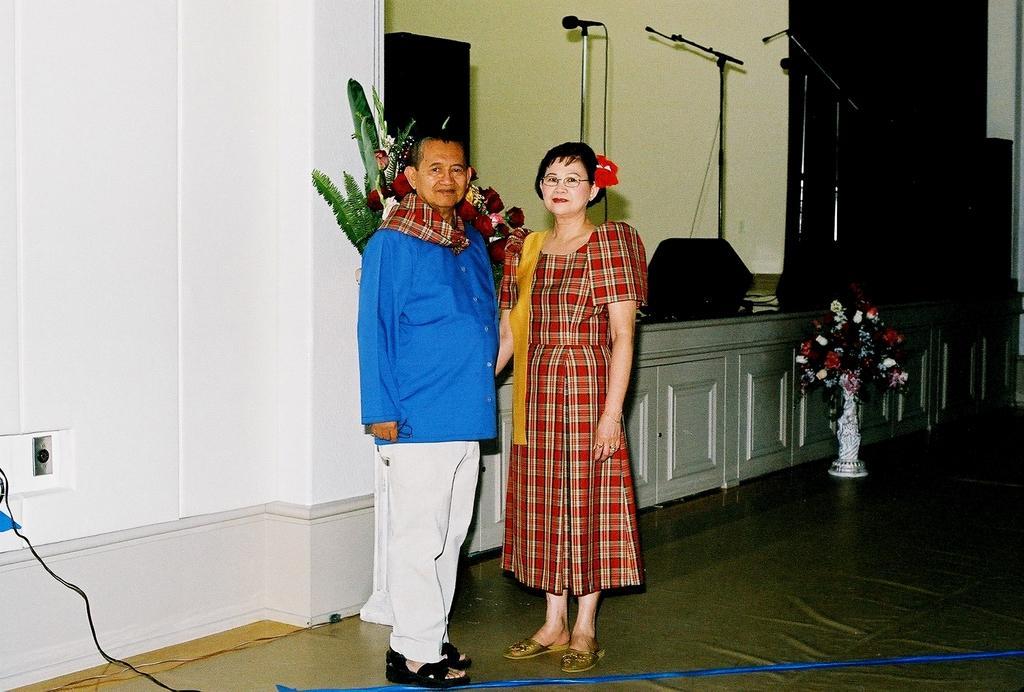In one or two sentences, can you explain what this image depicts? In this image in the center there are two persons who are standing, and in the background there is a table. On the table there is one flower bouquet and beside the table there is one pot and flowers, and on the table there are some mike's, speaker and some wires and on the left side there is a wall. At the bottom there is a floor. 